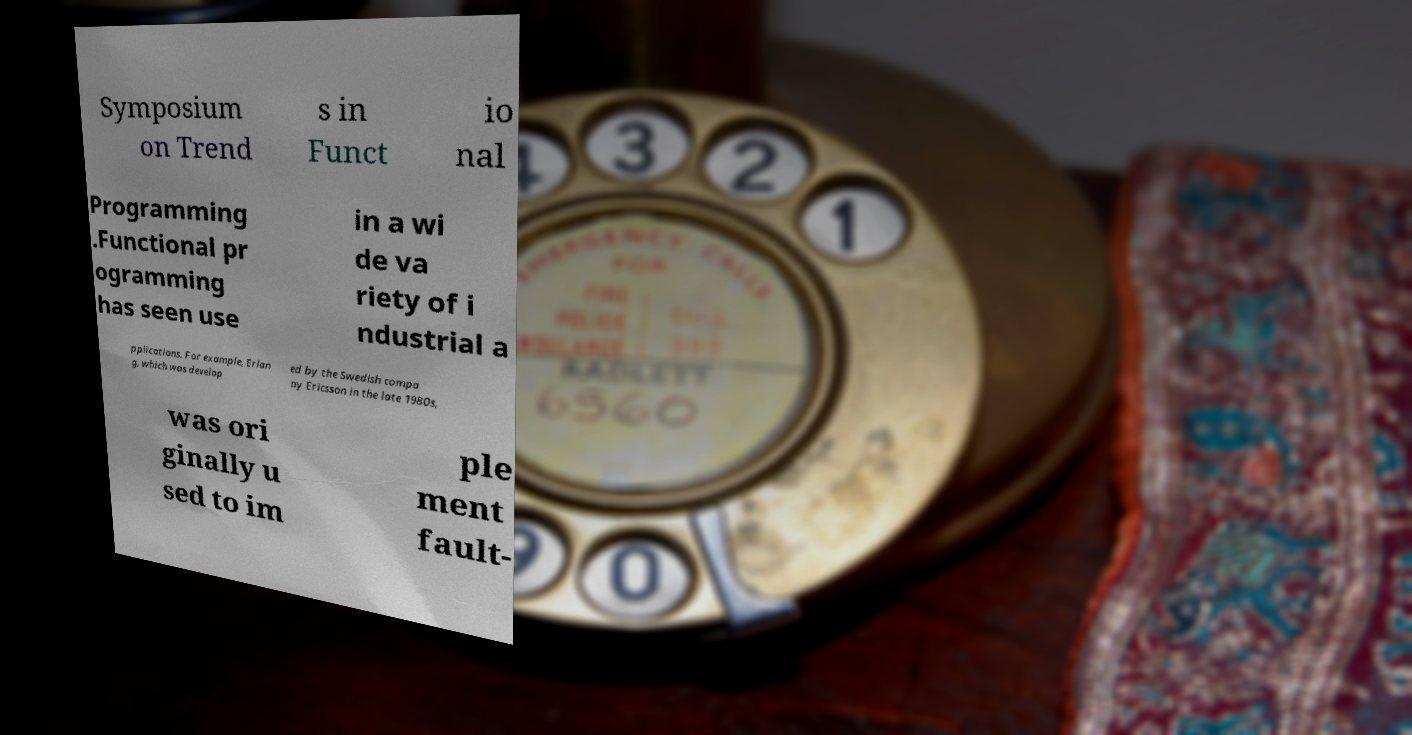Can you read and provide the text displayed in the image?This photo seems to have some interesting text. Can you extract and type it out for me? Symposium on Trend s in Funct io nal Programming .Functional pr ogramming has seen use in a wi de va riety of i ndustrial a pplications. For example, Erlan g, which was develop ed by the Swedish compa ny Ericsson in the late 1980s, was ori ginally u sed to im ple ment fault- 